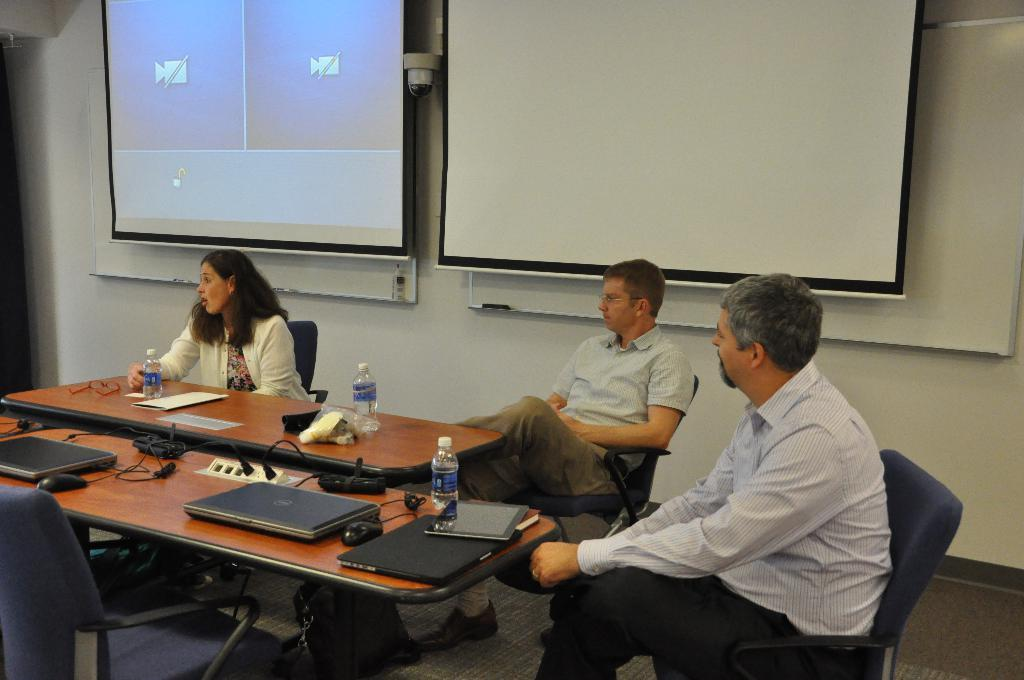How many people are in the image? There are four people in the image: one woman and two men. What are the people in the image doing? The woman and men are sitting on chairs. What objects can be seen on the table in the image? There are three laptops, three bottles, and a paper on the table. What can be seen in the background of the image? There are two projectors and a wall in the background. What type of unit is being measured in the image? There is no unit being measured in the image. When was the birth of the person in the image? There is no indication of a person's birth in the image. 